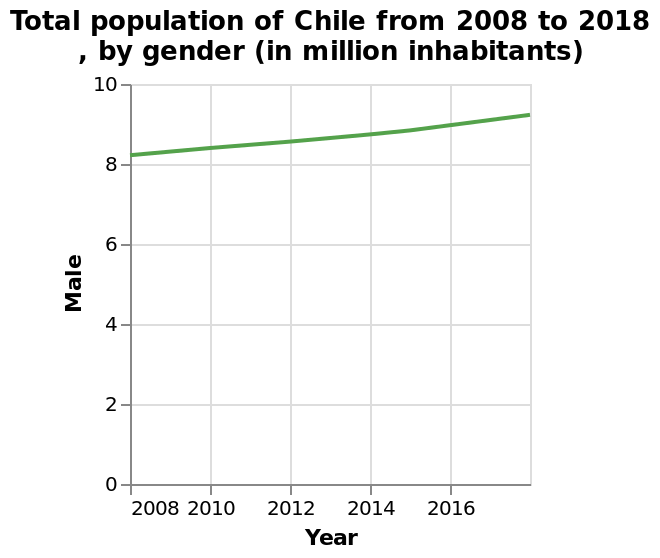<image>
please describe the details of the chart Total population of Chile from 2008 to 2018 , by gender (in million inhabitants) is a line chart. The y-axis measures Male along linear scale from 0 to 10 while the x-axis plots Year on linear scale from 2008 to 2016. Is the total population of Chile from 2008 to 2018, by gender (in million inhabitants) represented as a bar chart? No.Total population of Chile from 2008 to 2018 , by gender (in million inhabitants) is a line chart. The y-axis measures Male along linear scale from 0 to 10 while the x-axis plots Year on linear scale from 2008 to 2016. 